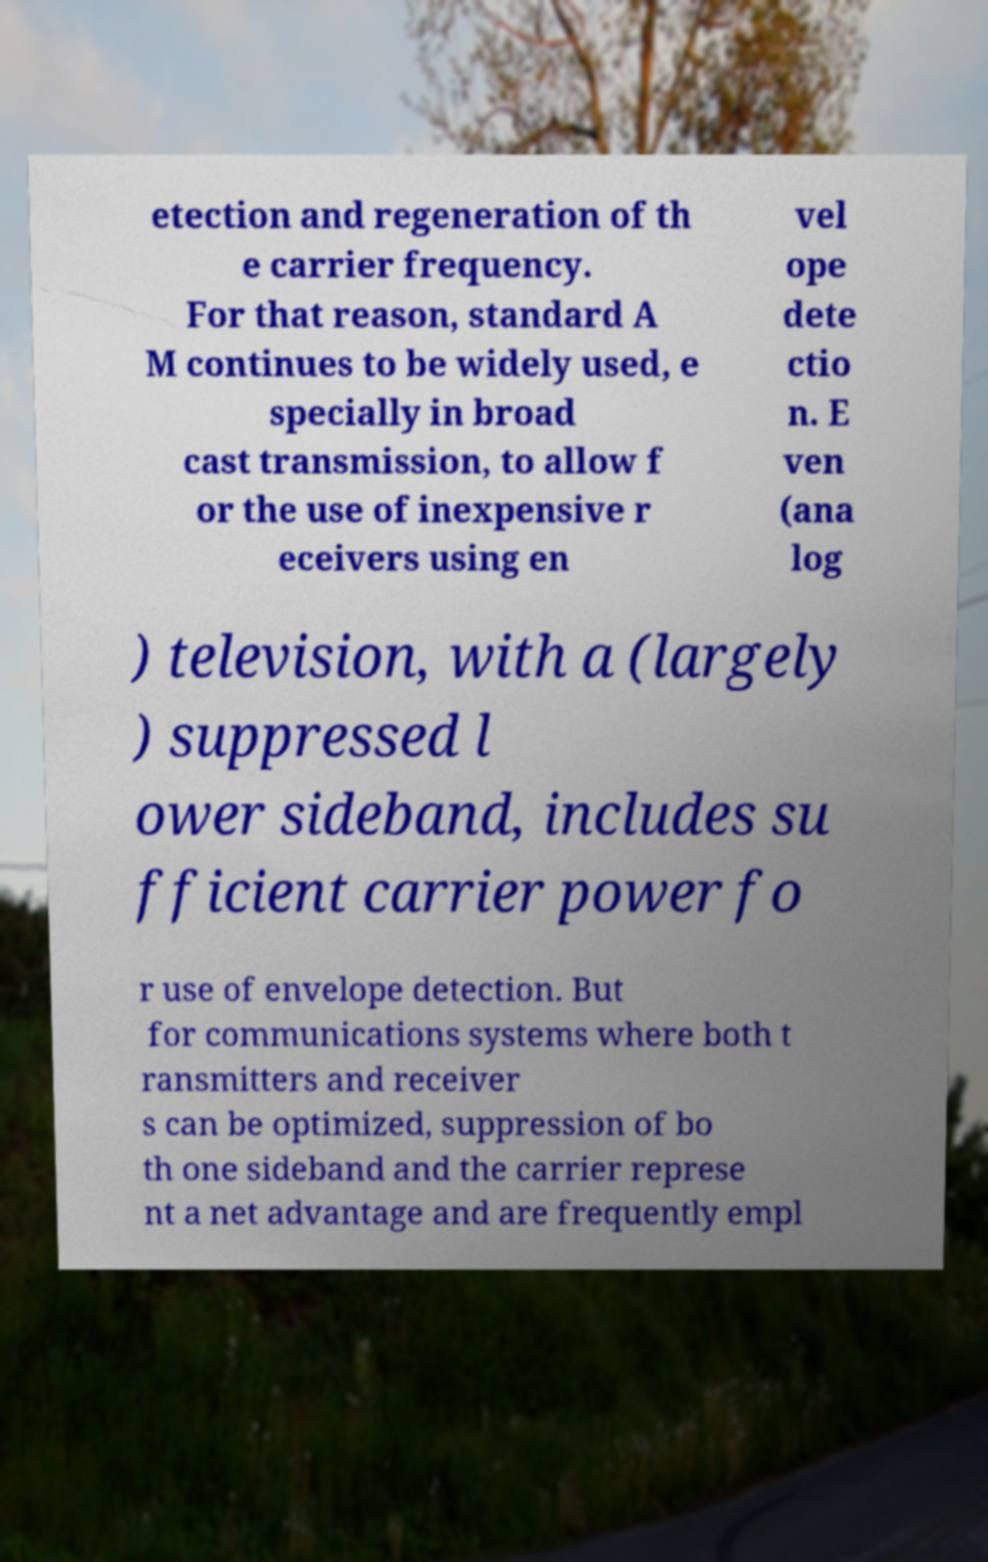Could you extract and type out the text from this image? etection and regeneration of th e carrier frequency. For that reason, standard A M continues to be widely used, e specially in broad cast transmission, to allow f or the use of inexpensive r eceivers using en vel ope dete ctio n. E ven (ana log ) television, with a (largely ) suppressed l ower sideband, includes su fficient carrier power fo r use of envelope detection. But for communications systems where both t ransmitters and receiver s can be optimized, suppression of bo th one sideband and the carrier represe nt a net advantage and are frequently empl 